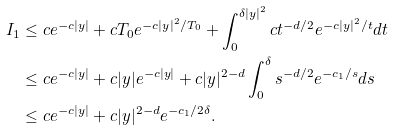Convert formula to latex. <formula><loc_0><loc_0><loc_500><loc_500>I _ { 1 } & \leq c e ^ { - c | y | } + c T _ { 0 } e ^ { - c | y | ^ { 2 } / T _ { 0 } } + \int _ { 0 } ^ { \delta | y | ^ { 2 } } c t ^ { - d / 2 } e ^ { - c | y | ^ { 2 } / t } d t \\ & \leq c e ^ { - c | y | } + c | y | e ^ { - c | y | } + c | y | ^ { 2 - d } \int _ { 0 } ^ { \delta } s ^ { - d / 2 } e ^ { - c _ { 1 } / s } d s \\ & \leq c e ^ { - c | y | } + c | y | ^ { 2 - d } e ^ { - c _ { 1 } / 2 \delta } .</formula> 